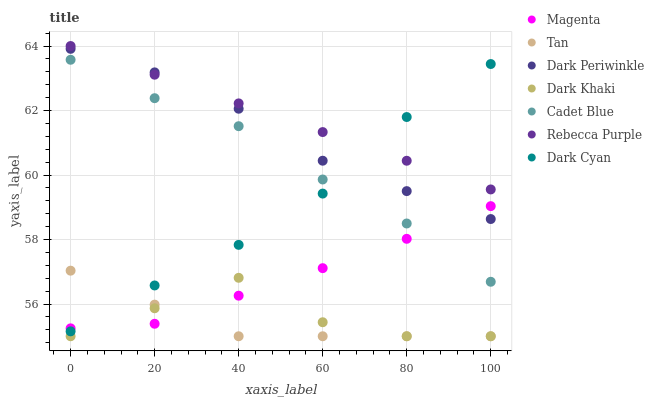Does Tan have the minimum area under the curve?
Answer yes or no. Yes. Does Rebecca Purple have the maximum area under the curve?
Answer yes or no. Yes. Does Dark Periwinkle have the minimum area under the curve?
Answer yes or no. No. Does Dark Periwinkle have the maximum area under the curve?
Answer yes or no. No. Is Rebecca Purple the smoothest?
Answer yes or no. Yes. Is Dark Khaki the roughest?
Answer yes or no. Yes. Is Dark Periwinkle the smoothest?
Answer yes or no. No. Is Dark Periwinkle the roughest?
Answer yes or no. No. Does Dark Khaki have the lowest value?
Answer yes or no. Yes. Does Dark Periwinkle have the lowest value?
Answer yes or no. No. Does Rebecca Purple have the highest value?
Answer yes or no. Yes. Does Dark Periwinkle have the highest value?
Answer yes or no. No. Is Cadet Blue less than Dark Periwinkle?
Answer yes or no. Yes. Is Dark Periwinkle greater than Cadet Blue?
Answer yes or no. Yes. Does Rebecca Purple intersect Dark Cyan?
Answer yes or no. Yes. Is Rebecca Purple less than Dark Cyan?
Answer yes or no. No. Is Rebecca Purple greater than Dark Cyan?
Answer yes or no. No. Does Cadet Blue intersect Dark Periwinkle?
Answer yes or no. No. 